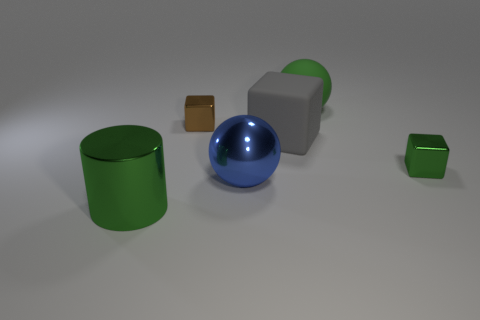What is the size of the matte cube?
Provide a short and direct response. Large. What is the size of the green rubber thing that is behind the large gray cube?
Provide a succinct answer. Large. There is a gray matte object behind the green shiny block; is its size the same as the large blue metal thing?
Your answer should be very brief. Yes. Are there any other things that are the same color as the large metal cylinder?
Your response must be concise. Yes. The large green matte object is what shape?
Your answer should be compact. Sphere. What number of small metal cubes are to the right of the green matte object and on the left side of the green matte object?
Your response must be concise. 0. Is the metallic ball the same color as the large cube?
Give a very brief answer. No. What material is the large blue thing that is the same shape as the big green rubber thing?
Keep it short and to the point. Metal. Are there any other things that are made of the same material as the gray thing?
Give a very brief answer. Yes. Are there an equal number of brown metallic objects in front of the brown cube and blue spheres in front of the big matte block?
Offer a terse response. No. 